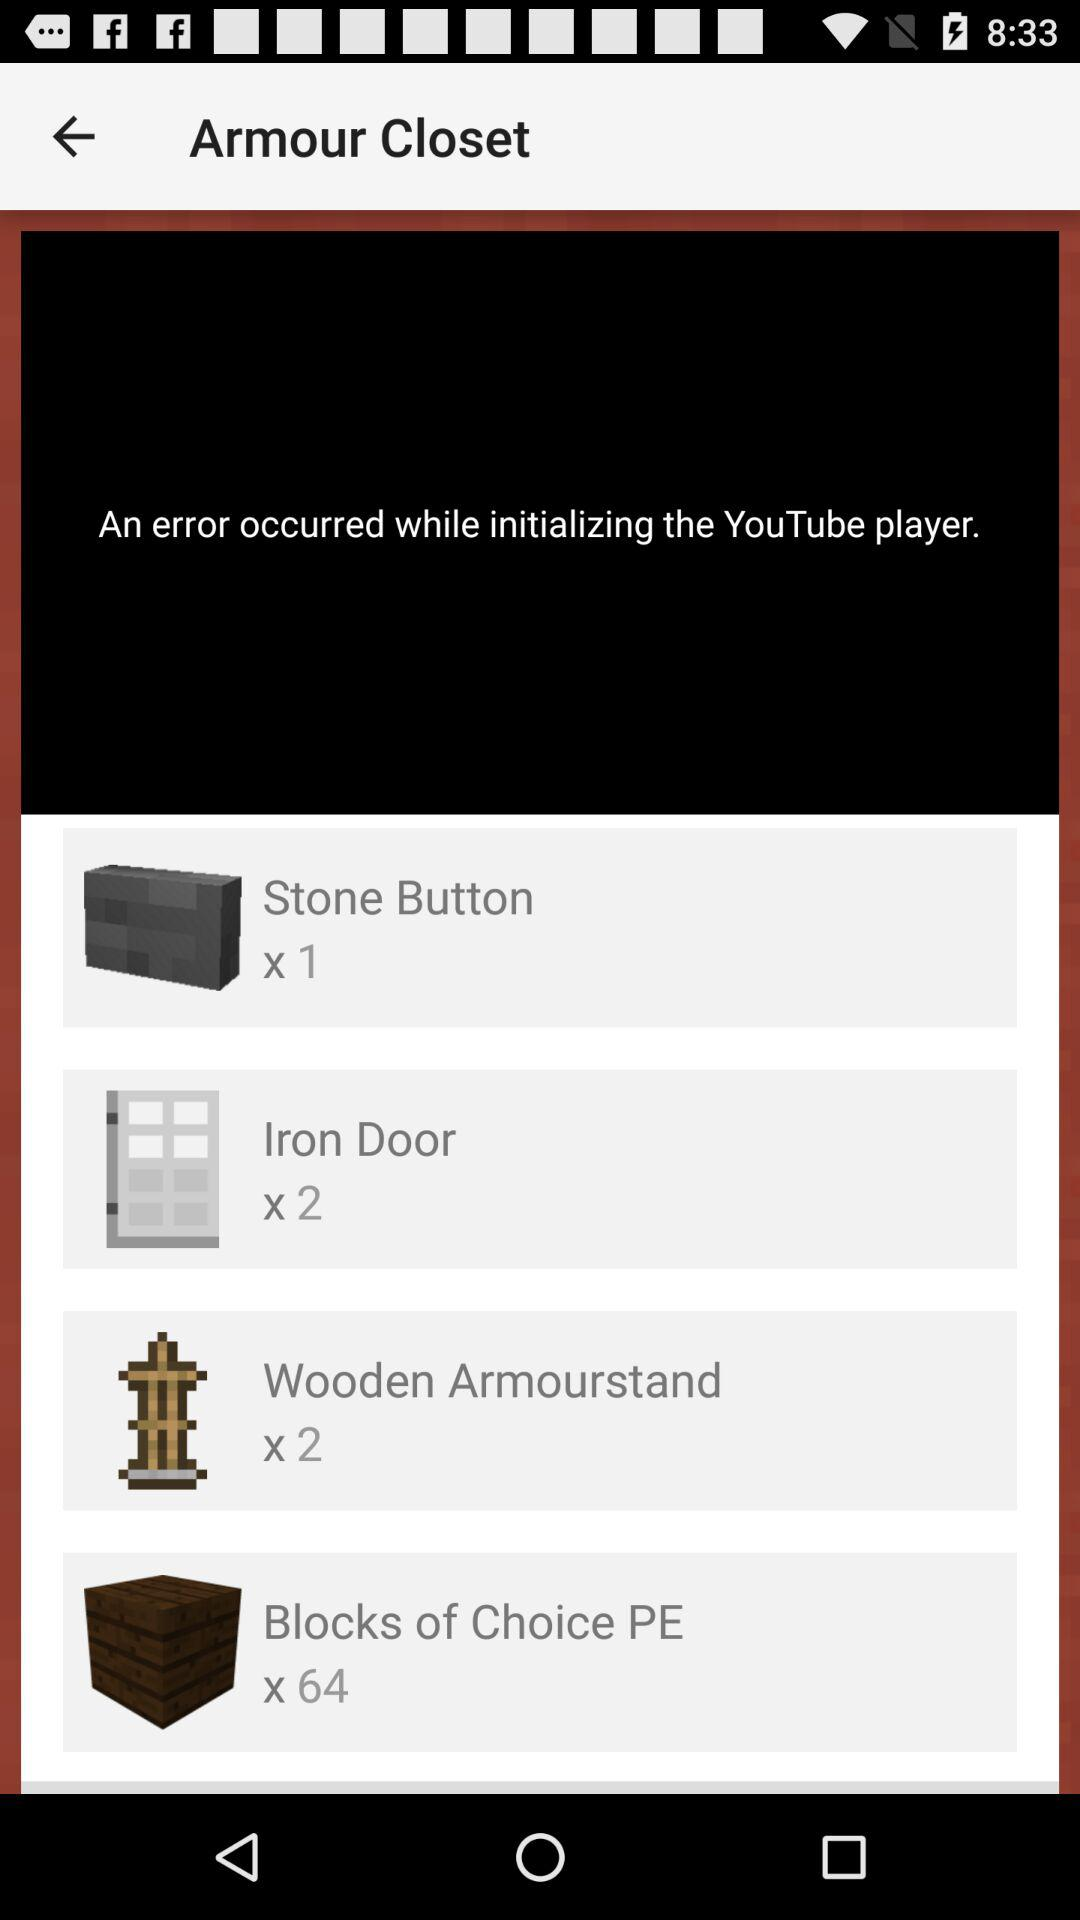How many "Stone Button" are there? There is 1 "Stone Button". 